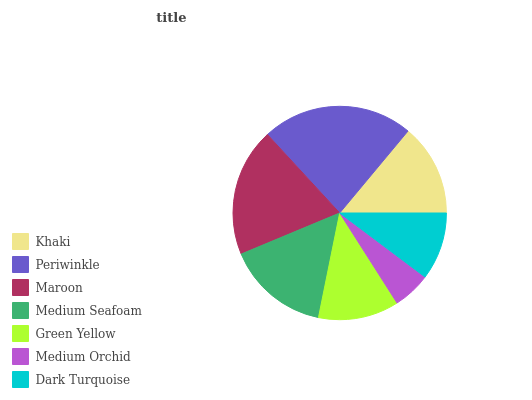Is Medium Orchid the minimum?
Answer yes or no. Yes. Is Periwinkle the maximum?
Answer yes or no. Yes. Is Maroon the minimum?
Answer yes or no. No. Is Maroon the maximum?
Answer yes or no. No. Is Periwinkle greater than Maroon?
Answer yes or no. Yes. Is Maroon less than Periwinkle?
Answer yes or no. Yes. Is Maroon greater than Periwinkle?
Answer yes or no. No. Is Periwinkle less than Maroon?
Answer yes or no. No. Is Khaki the high median?
Answer yes or no. Yes. Is Khaki the low median?
Answer yes or no. Yes. Is Medium Orchid the high median?
Answer yes or no. No. Is Dark Turquoise the low median?
Answer yes or no. No. 